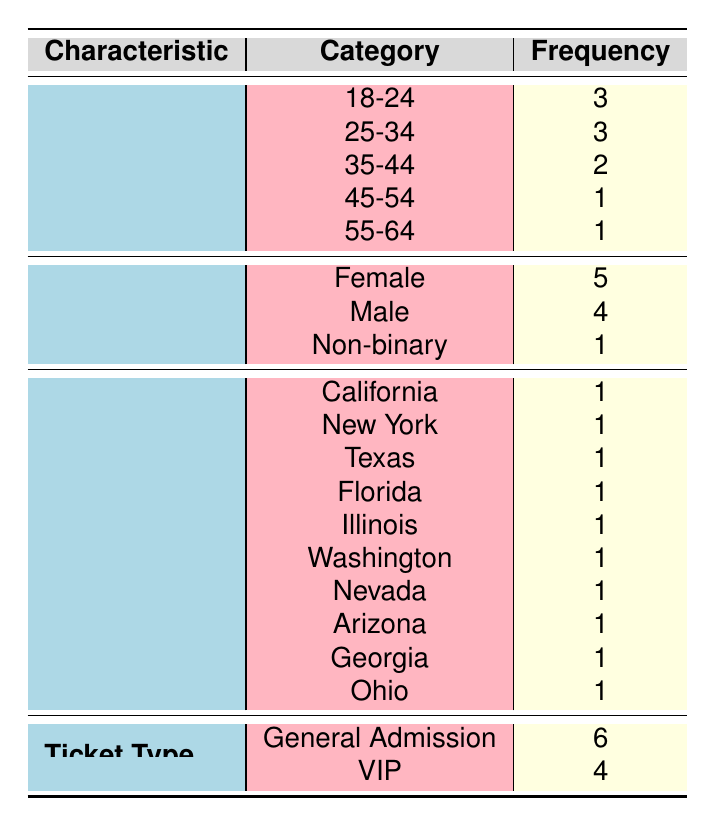What is the total number of attendees in the 18-24 age group? There are 3 attendees listed under the 18-24 age group in the table.
Answer: 3 What percentage of total attendees are Non-binary? There is 1 Non-binary attendee out of a total of 10 attendees. The percentage is calculated as (1/10) * 100 = 10%.
Answer: 10% Which age group has the highest frequency of attendees? The age groups 18-24 and 25-34 both have 3 attendees each, which is the highest frequency recorded in the table.
Answer: 18-24 and 25-34 Is there any attendee from the region of Ohio? Yes, there is 1 attendee from Ohio, as listed in the region section of the table.
Answer: Yes What is the average age group frequency for all attendees? The total frequency of attendees across age groups is (3 + 3 + 2 + 1 + 1) = 10. There are 5 distinct age groups, so the average is 10 / 5 = 2.
Answer: 2 How many more females attended compared to Non-binary individuals? There are 5 females and 1 Non-binary attendee. The difference is calculated as 5 - 1 = 4.
Answer: 4 What is the total frequency of General Admission ticket holders? The table states there are 6 General Admission ticket holders, which is the frequency under the Ticket Type section.
Answer: 6 Which gender has the lowest frequency among attendees? Non-binary has the lowest frequency with only 1 attendee, as seen in the gender section of the table.
Answer: Non-binary What is the total number of VIP ticket holders from attendees aged 35-44? There is 1 VIP ticket holder in the 35-44 age group based on the information presented in the table.
Answer: 1 